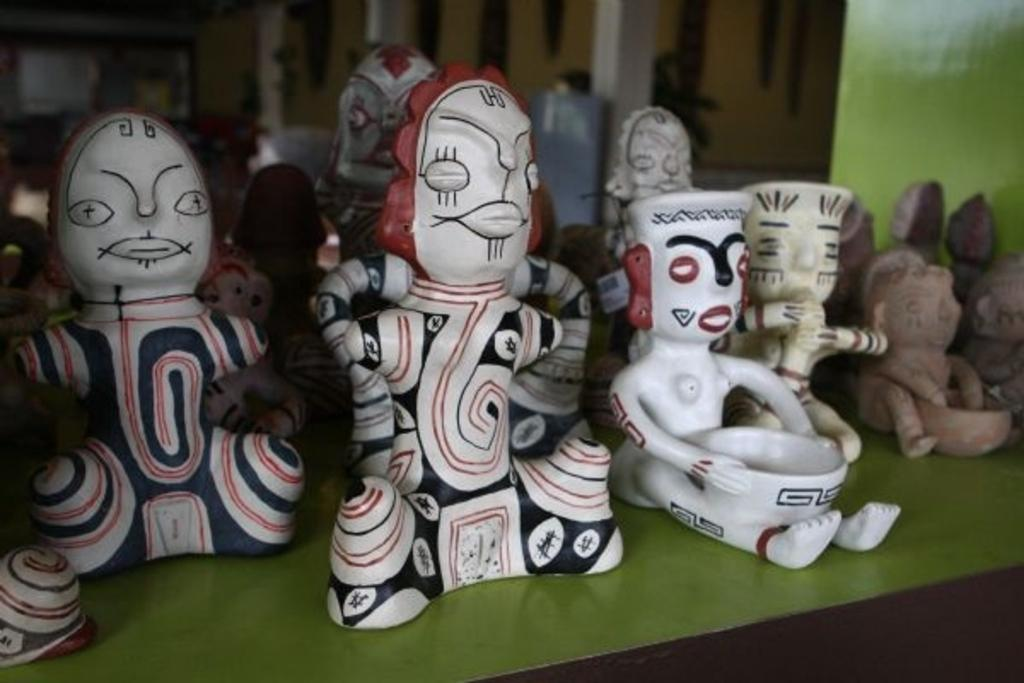What type of toys are in the image? There are dolls in the image. What is the platform made of that the dolls are on? The dolls are on a green platform. Can you describe the background of the image? The background of the image is blurry. What else can be seen in the background besides the blurriness? There are objects visible in the background. What type of soup is being served in the image? There is no soup present in the image; it features dolls on a green platform with a blurry background. 